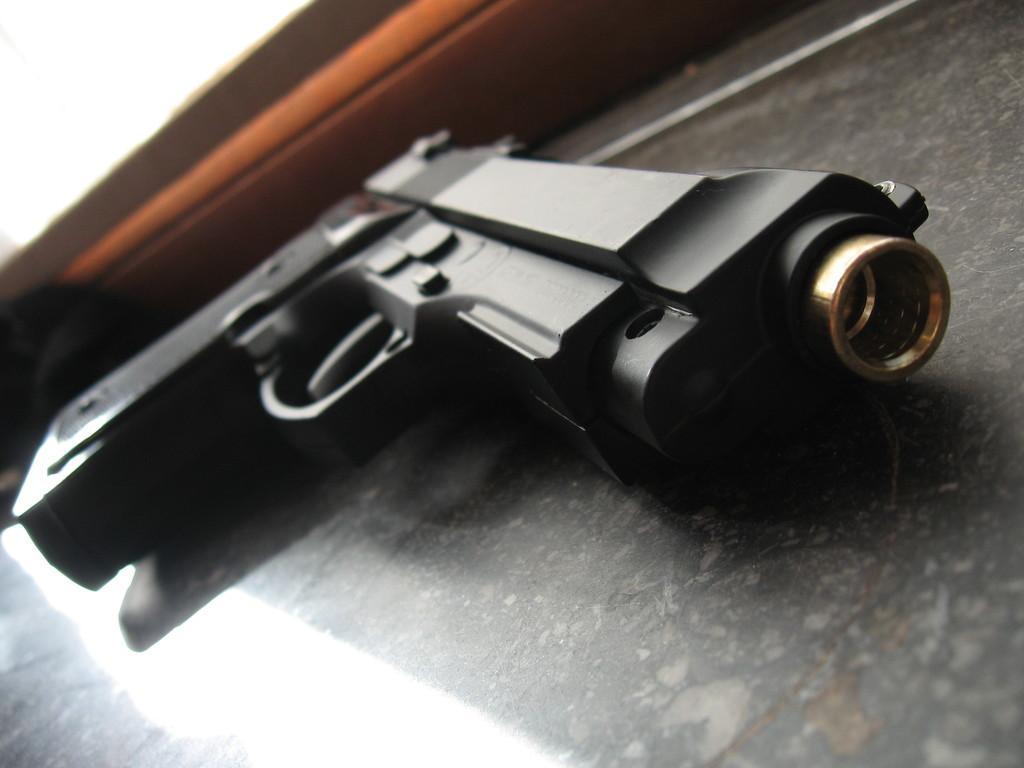Please provide a concise description of this image. In this picture I can see a gun and a wall in the background. 